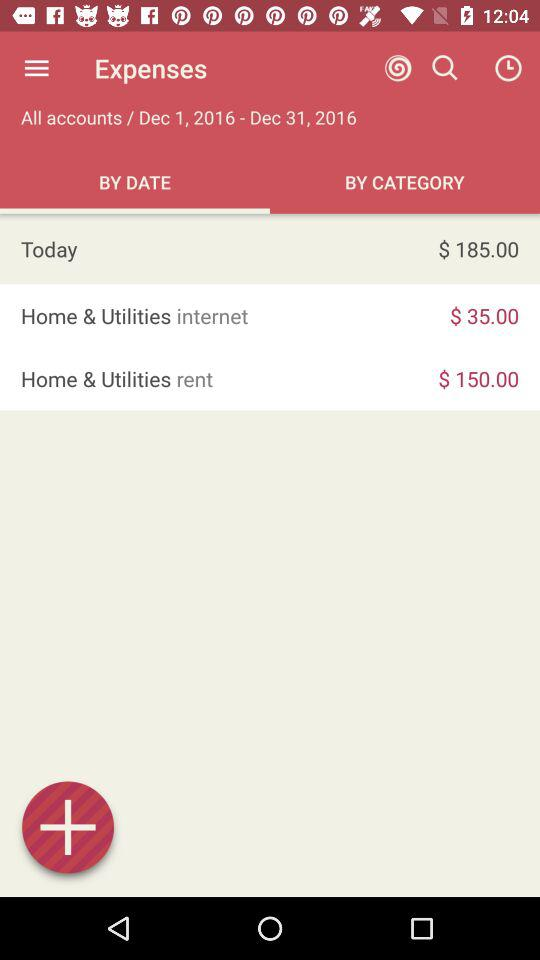What is the date range for which the expenses are shown? The date range for which the expenses are shown is December 1, 2016 to December 31, 2016. 